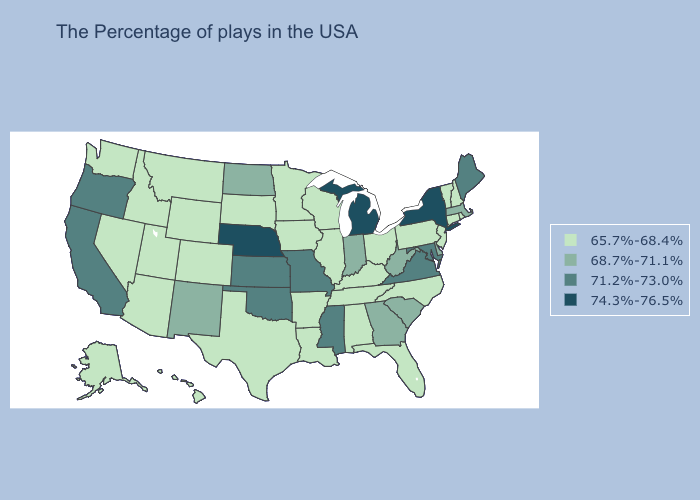Does Delaware have a higher value than Arizona?
Keep it brief. Yes. What is the value of Tennessee?
Quick response, please. 65.7%-68.4%. What is the lowest value in the Northeast?
Write a very short answer. 65.7%-68.4%. Among the states that border Kansas , which have the lowest value?
Short answer required. Colorado. Name the states that have a value in the range 65.7%-68.4%?
Concise answer only. Rhode Island, New Hampshire, Vermont, Connecticut, New Jersey, Pennsylvania, North Carolina, Ohio, Florida, Kentucky, Alabama, Tennessee, Wisconsin, Illinois, Louisiana, Arkansas, Minnesota, Iowa, Texas, South Dakota, Wyoming, Colorado, Utah, Montana, Arizona, Idaho, Nevada, Washington, Alaska, Hawaii. What is the value of Mississippi?
Quick response, please. 71.2%-73.0%. What is the value of Georgia?
Be succinct. 68.7%-71.1%. What is the value of Indiana?
Short answer required. 68.7%-71.1%. Among the states that border Indiana , which have the highest value?
Write a very short answer. Michigan. Name the states that have a value in the range 68.7%-71.1%?
Quick response, please. Massachusetts, Delaware, South Carolina, West Virginia, Georgia, Indiana, North Dakota, New Mexico. Among the states that border Arizona , which have the lowest value?
Keep it brief. Colorado, Utah, Nevada. Does New York have the highest value in the Northeast?
Keep it brief. Yes. Name the states that have a value in the range 71.2%-73.0%?
Quick response, please. Maine, Maryland, Virginia, Mississippi, Missouri, Kansas, Oklahoma, California, Oregon. What is the value of North Dakota?
Write a very short answer. 68.7%-71.1%. 